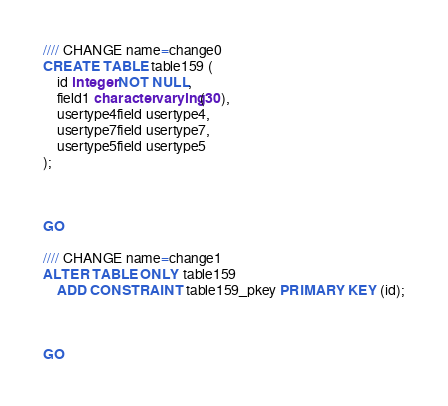<code> <loc_0><loc_0><loc_500><loc_500><_SQL_>//// CHANGE name=change0
CREATE TABLE table159 (
    id integer NOT NULL,
    field1 character varying(30),
    usertype4field usertype4,
    usertype7field usertype7,
    usertype5field usertype5
);



GO

//// CHANGE name=change1
ALTER TABLE ONLY table159
    ADD CONSTRAINT table159_pkey PRIMARY KEY (id);



GO
</code> 